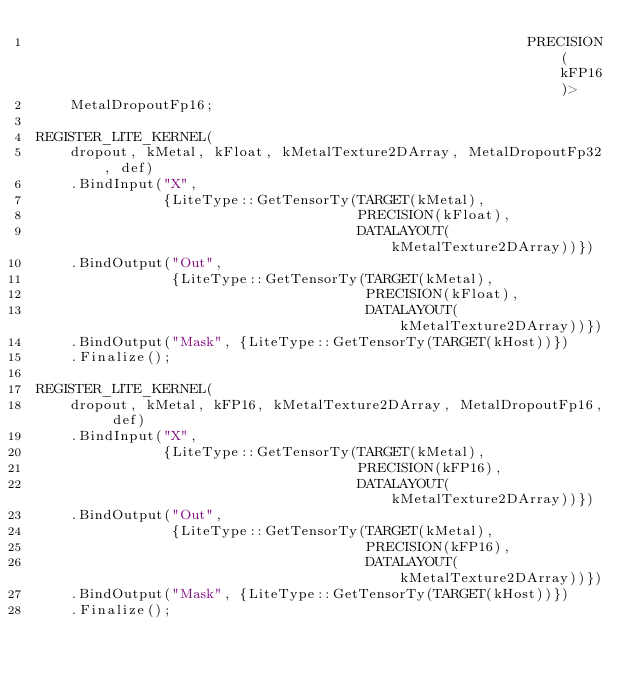Convert code to text. <code><loc_0><loc_0><loc_500><loc_500><_ObjectiveC_>                                                          PRECISION(kFP16)>
    MetalDropoutFp16;

REGISTER_LITE_KERNEL(
    dropout, kMetal, kFloat, kMetalTexture2DArray, MetalDropoutFp32, def)
    .BindInput("X",
               {LiteType::GetTensorTy(TARGET(kMetal),
                                      PRECISION(kFloat),
                                      DATALAYOUT(kMetalTexture2DArray))})
    .BindOutput("Out",
                {LiteType::GetTensorTy(TARGET(kMetal),
                                       PRECISION(kFloat),
                                       DATALAYOUT(kMetalTexture2DArray))})
    .BindOutput("Mask", {LiteType::GetTensorTy(TARGET(kHost))})
    .Finalize();

REGISTER_LITE_KERNEL(
    dropout, kMetal, kFP16, kMetalTexture2DArray, MetalDropoutFp16, def)
    .BindInput("X",
               {LiteType::GetTensorTy(TARGET(kMetal),
                                      PRECISION(kFP16),
                                      DATALAYOUT(kMetalTexture2DArray))})
    .BindOutput("Out",
                {LiteType::GetTensorTy(TARGET(kMetal),
                                       PRECISION(kFP16),
                                       DATALAYOUT(kMetalTexture2DArray))})
    .BindOutput("Mask", {LiteType::GetTensorTy(TARGET(kHost))})
    .Finalize();</code> 